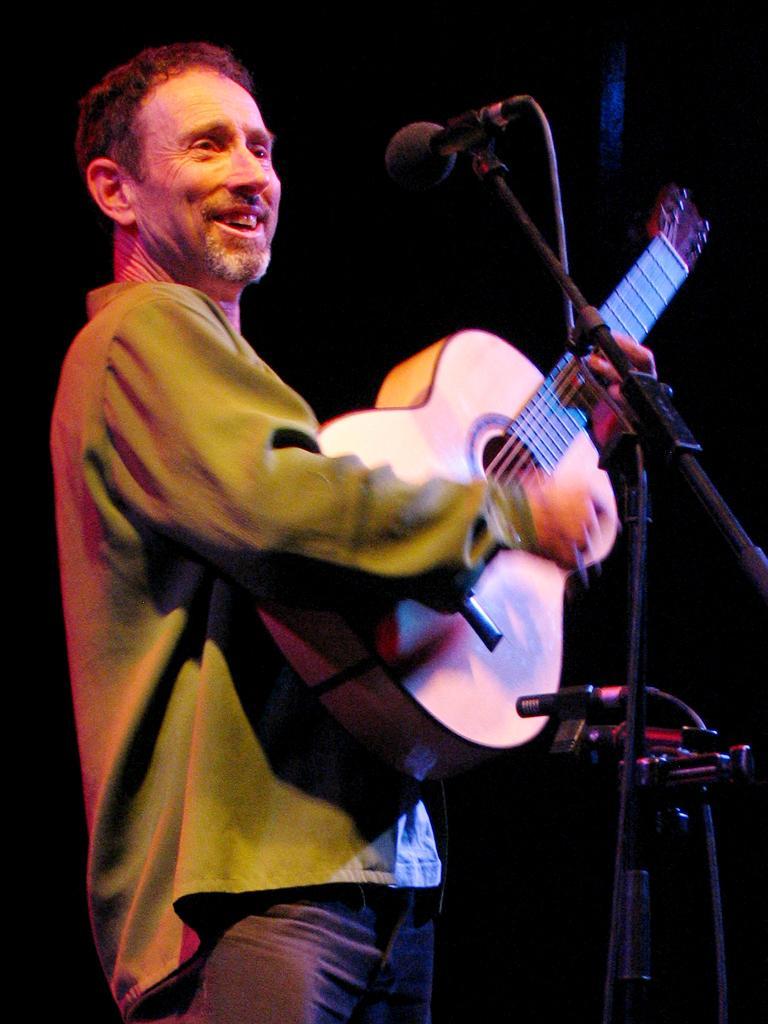Please provide a concise description of this image. This picture shows a man playing a guitar in his hands. He is smiling. In front of him there is a mic and a stand. In the background there is dark. 